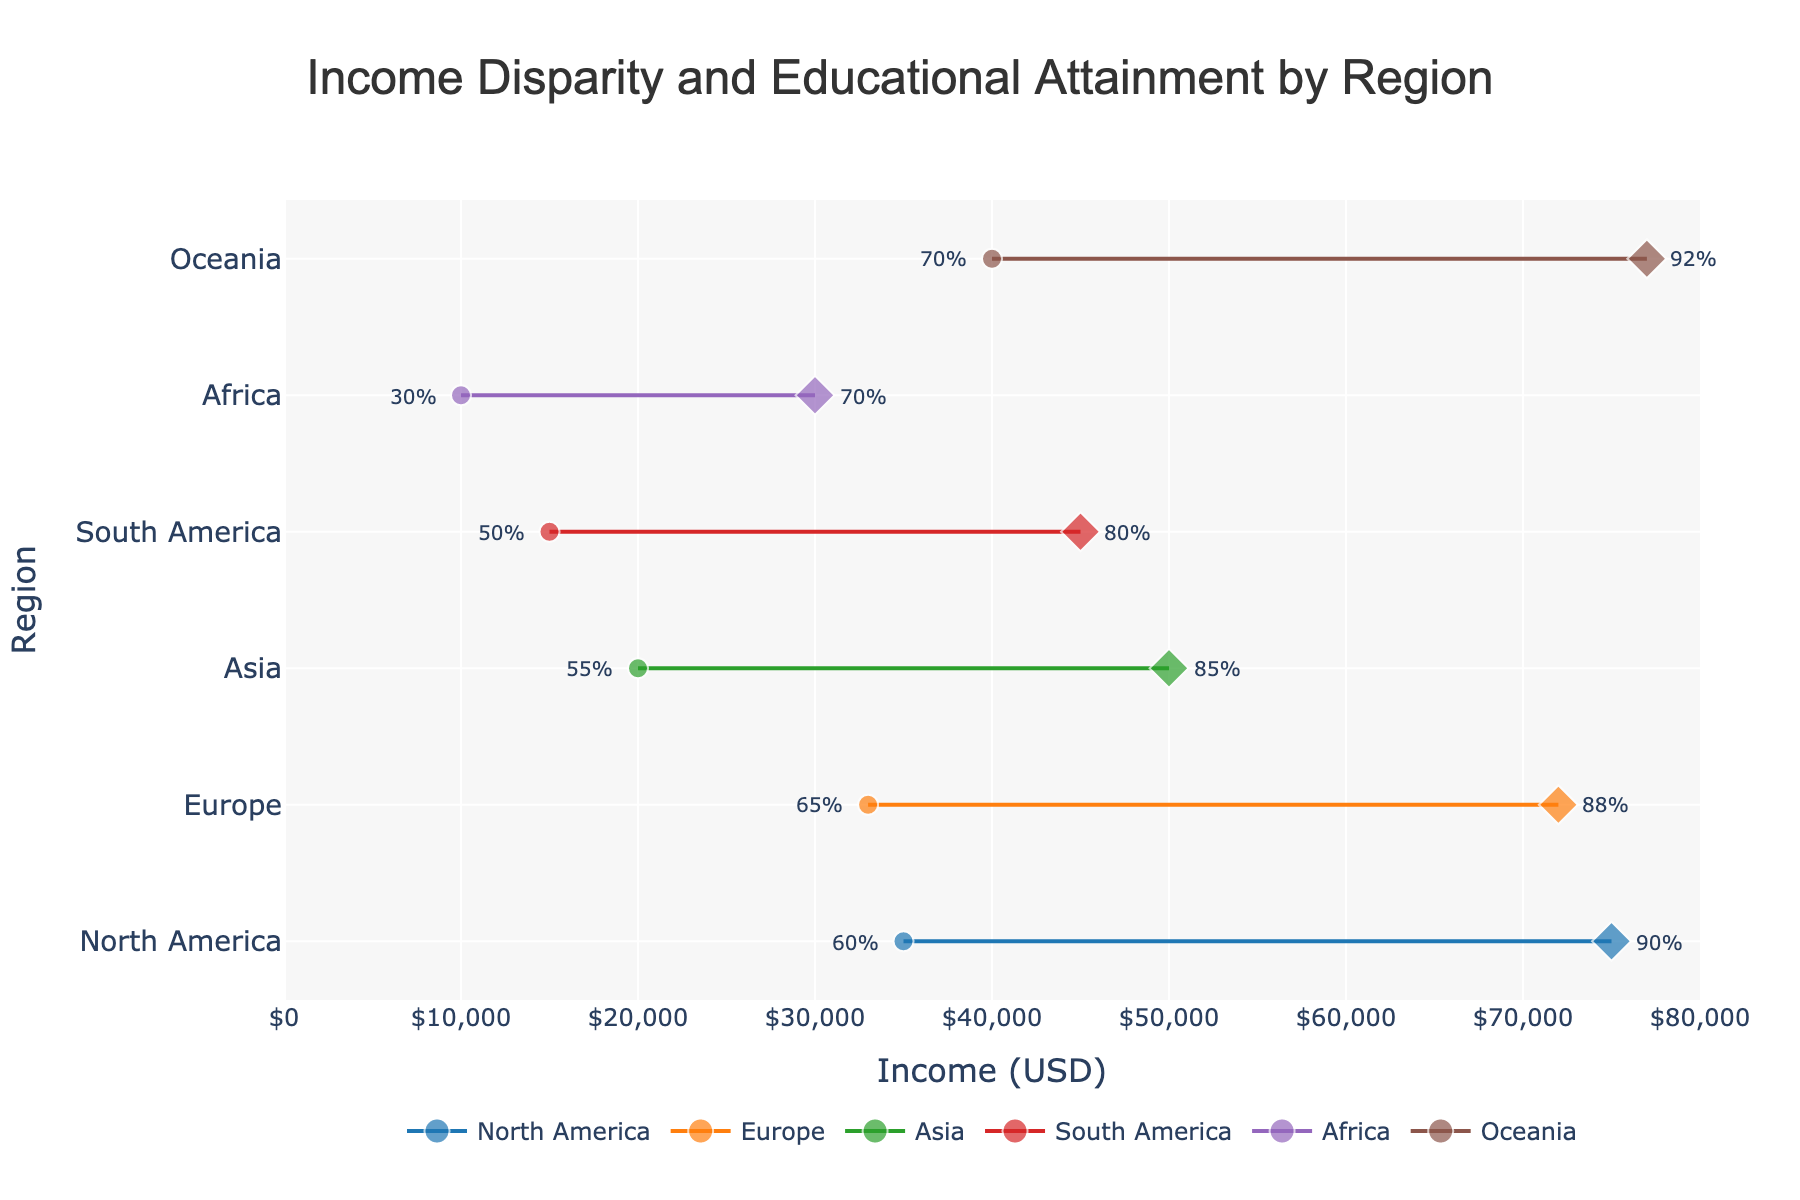What is the title of the figure? The title is found at the top of the figure, typically in larger font, summarizing the purpose of the plot.
Answer: Income Disparity and Educational Attainment by Region What is the range of income on the x-axis? The x-axis title “Income (USD)” suggests it displays income values. Inspecting the range of the axis ticks confirms it spans from 0 to 80,000 USD.
Answer: 0 to 80,000 USD Which region has the highest income for high educational attainment? By examining the end points (diamonds) of each region's line for the maximum x-axis value, Oceania has the highest income at 77,000 USD.
Answer: Oceania What is the income gap between low and high educational attainment in North America? To find the income gap for North America, subtract the low educational attainment income (35,000 USD) from the high educational attainment income (75,000 USD): 75,000 - 35,000 = 40,000 USD.
Answer: 40,000 USD Which region has the lowest income for low educational attainment? Check the starting points (circles) of each region's line for the minimum x-axis value; Africa has the lowest income at 10,000 USD.
Answer: Africa What is the difference in educational attainment percentages between low and high education in Asia? Subtract the low educational attainment percentage (55%) from the high educational attainment percentage (85%): 85% - 55% = 30%.
Answer: 30% How many regions are displayed in the figure? The figure consists of 6 different lines, each associated with a region; therefore, there are 6 regions shown.
Answer: 6 Is the income disparity larger in South America or Europe? Calculate the income disparity for each: South America (45,000 - 15,000 = 30,000 USD) and Europe (72,000 - 33,000 = 39,000 USD). Europe's disparity (39,000) is larger than South America's (30,000).
Answer: Europe Which region has the largest range of educational attainment percentages? Calculate the range for each region, and find the largest: Africa (70% - 30% = 40%), Asia (85% - 55% = 30%), etc. Africa has the largest range at 40%.
Answer: Africa Which region has similar income levels for both low and high educational attainment? Compare the income disparities; Oceania has a disparity of 37,000 and North America is relatively less but not similar. South America has low variance, but Europe and Asia show distinct variances. Finally, all regions show evident disparities; no region has very similar income levels for both educational attainments.
Answer: None 